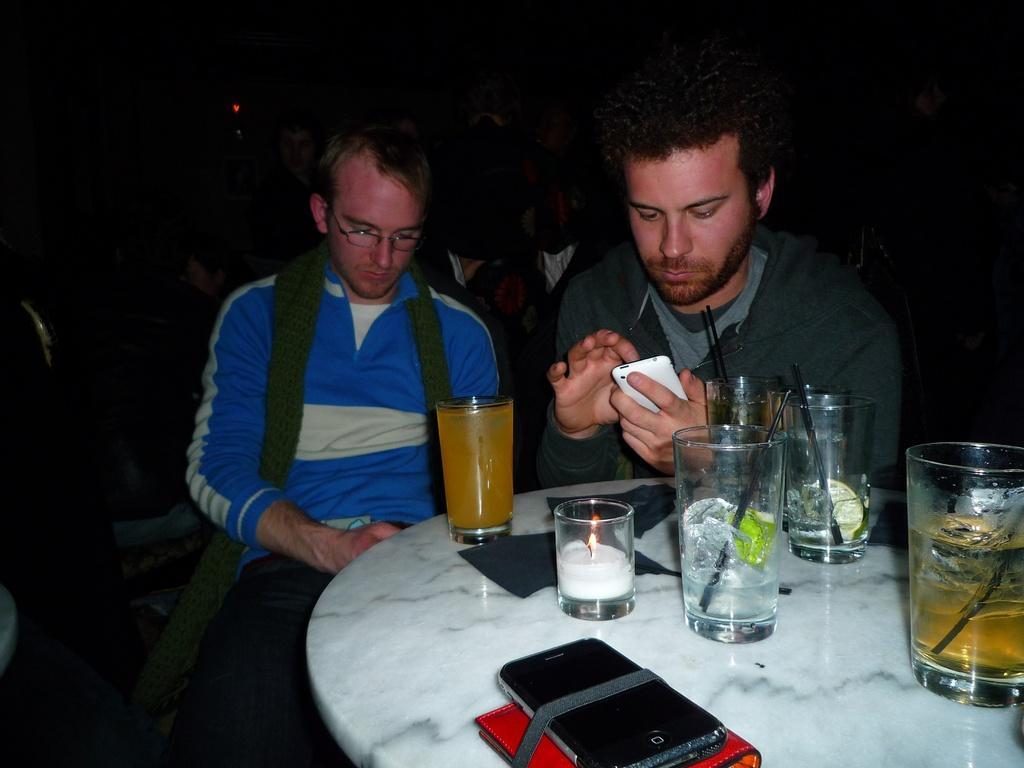Please provide a concise description of this image. In the foreground of this image, there is a table on which glasses, a candle, mobile phone and a wallet are placed. In the background, there are two men sitting on the chairs. One man is holding a mobile phone. In the background, there are persons in the dark. 